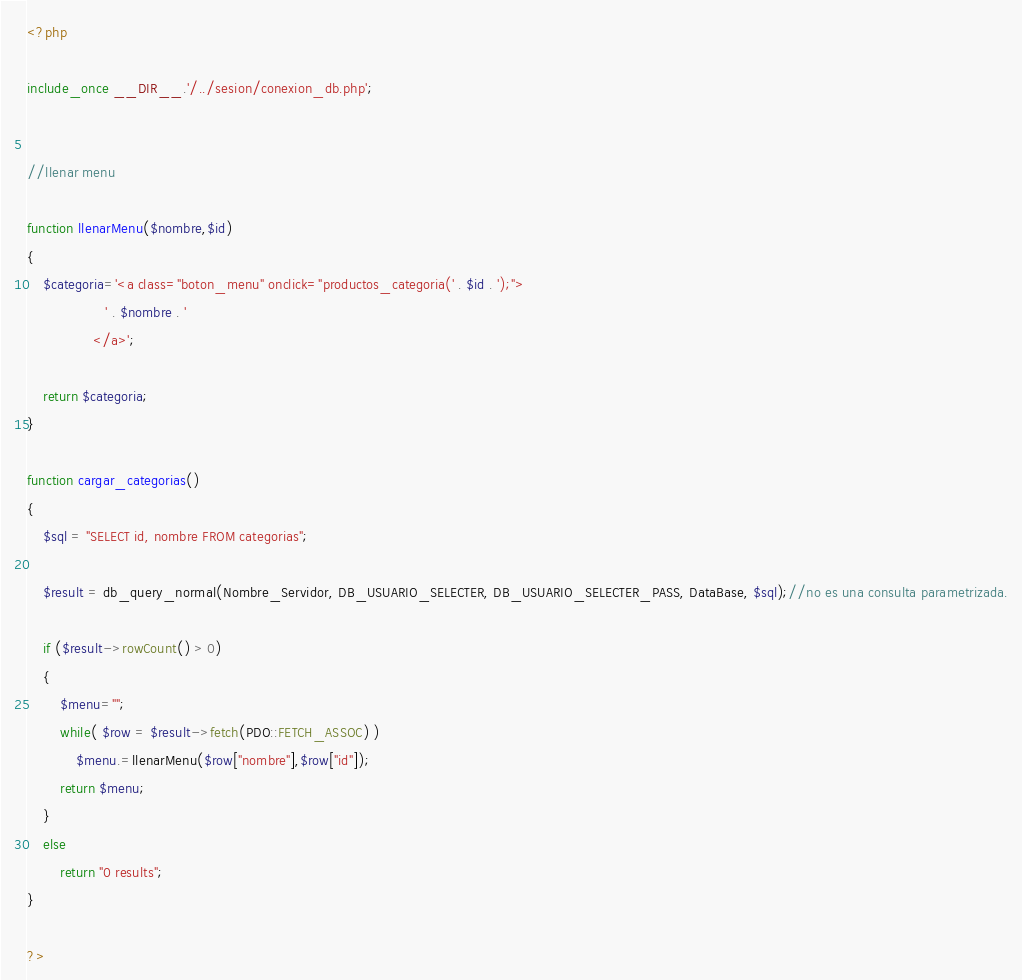Convert code to text. <code><loc_0><loc_0><loc_500><loc_500><_PHP_><?php

include_once __DIR__.'/../sesion/conexion_db.php';


//llenar menu

function llenarMenu($nombre,$id)
{
    $categoria='<a class="boton_menu" onclick="productos_categoria(' . $id . ');">
                   ' . $nombre . '
                </a>';

    return $categoria;
}

function cargar_categorias()
{
    $sql = "SELECT id, nombre FROM categorias";

    $result = db_query_normal(Nombre_Servidor, DB_USUARIO_SELECTER, DB_USUARIO_SELECTER_PASS, DataBase, $sql);//no es una consulta parametrizada.

    if ($result->rowCount() > 0) 
    {
        $menu="";
        while( $row = $result->fetch(PDO::FETCH_ASSOC) ) 
            $menu.=llenarMenu($row["nombre"],$row["id"]);
        return $menu;
    } 
    else 
        return "0 results";
}

?></code> 